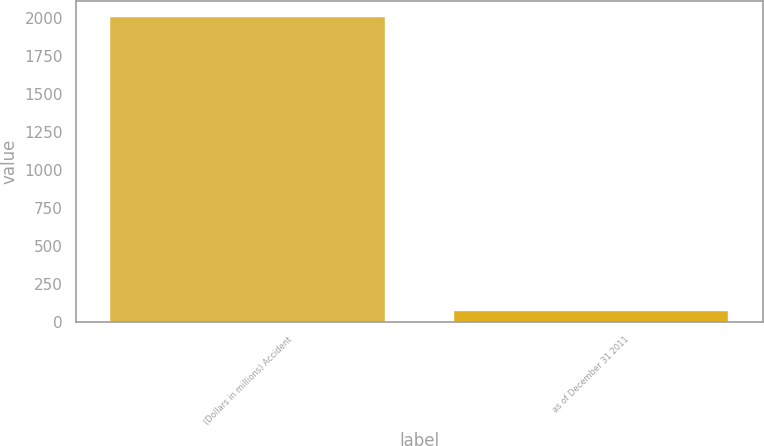<chart> <loc_0><loc_0><loc_500><loc_500><bar_chart><fcel>(Dollars in millions) Accident<fcel>as of December 31 2011<nl><fcel>2010<fcel>72.3<nl></chart> 